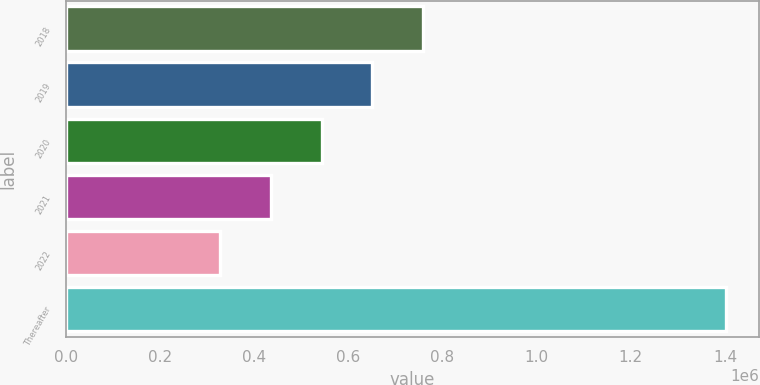Convert chart to OTSL. <chart><loc_0><loc_0><loc_500><loc_500><bar_chart><fcel>2018<fcel>2019<fcel>2020<fcel>2021<fcel>2022<fcel>Thereafter<nl><fcel>757985<fcel>650564<fcel>543143<fcel>435723<fcel>328302<fcel>1.40251e+06<nl></chart> 